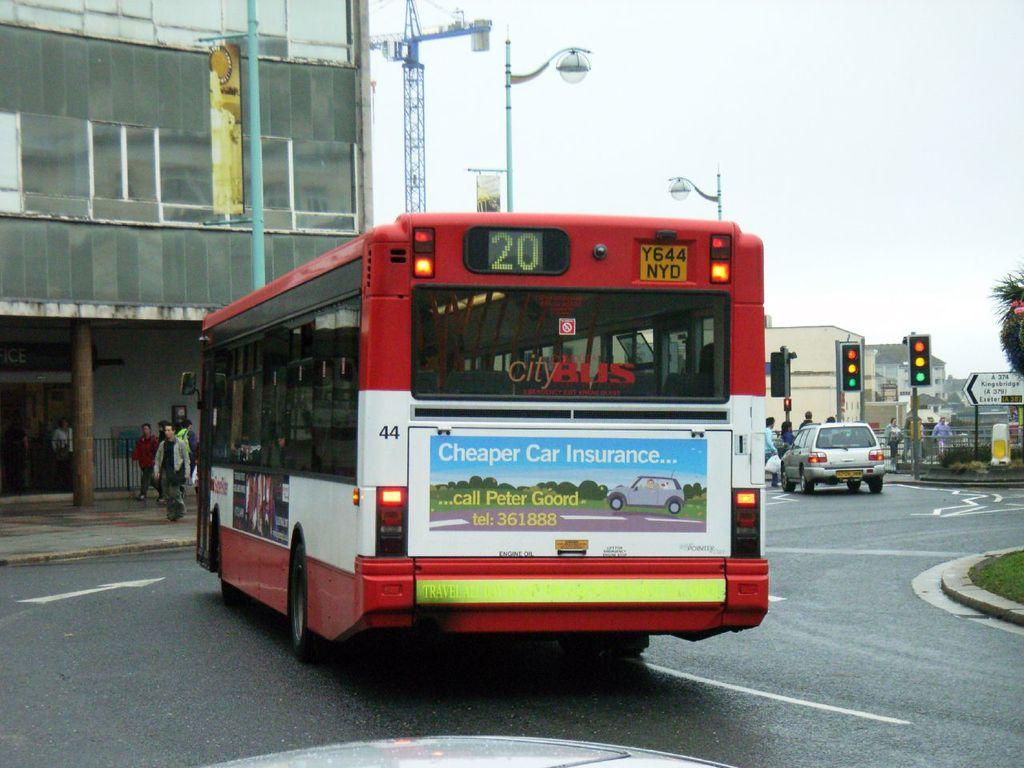What can be seen on the road in the image? There are vehicles on the road in the image. What type of vegetation is visible in the image? There is grass visible in the image. What structures can be seen in the background of the image? There are buildings, boards, and a traffic signal mounted on a pole in the background. What else is present in the background of the image? A crane, a tree, a fence, plants, and lights are visible in the background. What part of the natural environment is visible in the image? The sky is visible in the background of the image. What month is it in the image? The month cannot be determined from the image, as there is no information about the time of year. What type of tree is present in the image? There is no specific type of tree mentioned in the facts, only that a tree is present in the background. What is the purpose of the umbrella in the image? There is no umbrella present in the image. 